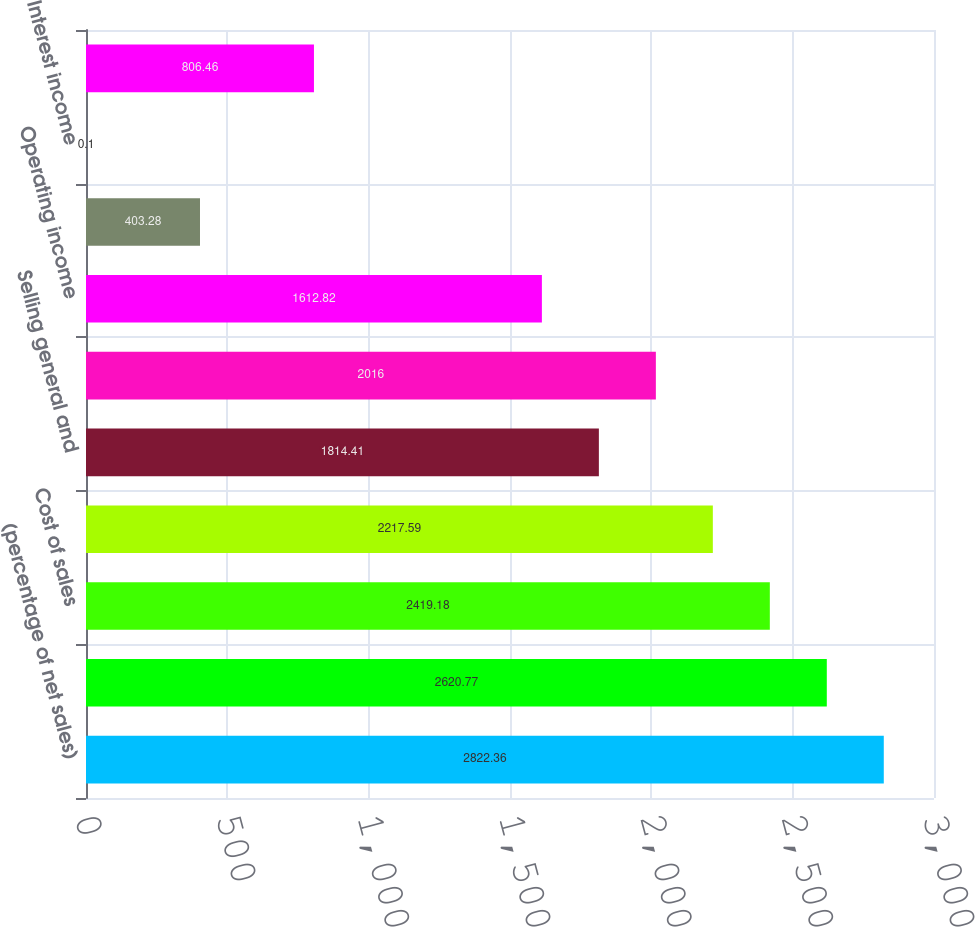<chart> <loc_0><loc_0><loc_500><loc_500><bar_chart><fcel>(percentage of net sales)<fcel>Net sales<fcel>Cost of sales<fcel>Gross profit<fcel>Selling general and<fcel>Other expense net<fcel>Operating income<fcel>Equity in affiliates' earnings<fcel>Interest income<fcel>Interest expense and finance<nl><fcel>2822.36<fcel>2620.77<fcel>2419.18<fcel>2217.59<fcel>1814.41<fcel>2016<fcel>1612.82<fcel>403.28<fcel>0.1<fcel>806.46<nl></chart> 